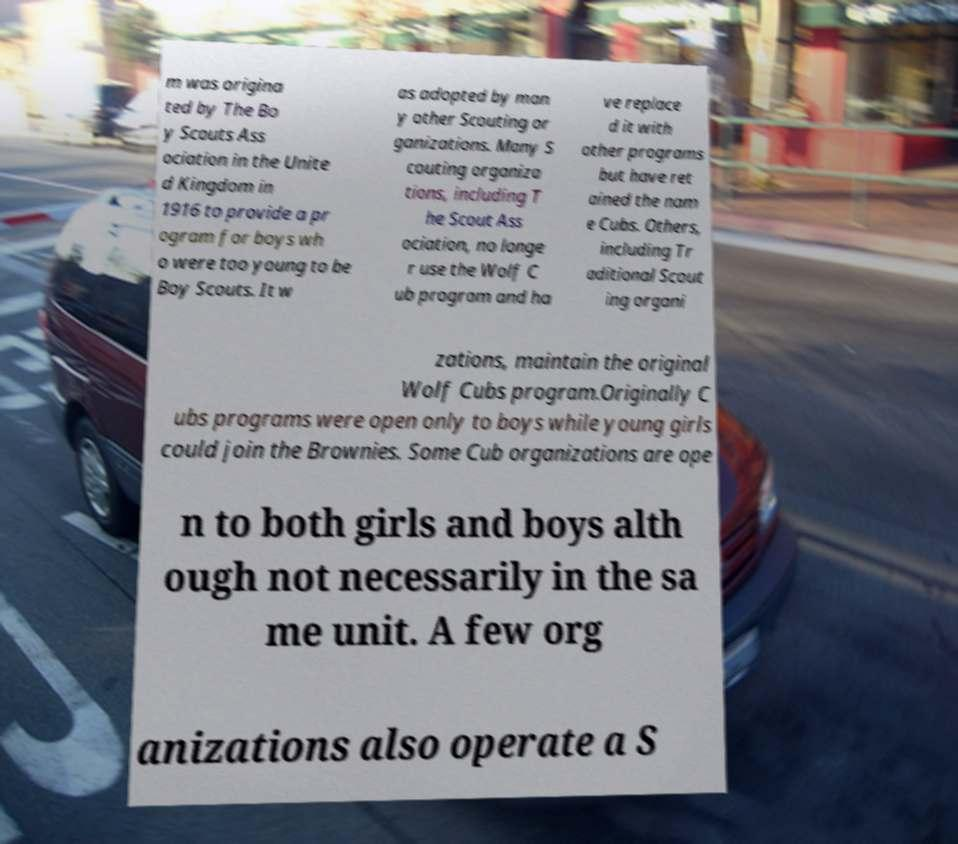What messages or text are displayed in this image? I need them in a readable, typed format. m was origina ted by The Bo y Scouts Ass ociation in the Unite d Kingdom in 1916 to provide a pr ogram for boys wh o were too young to be Boy Scouts. It w as adopted by man y other Scouting or ganizations. Many S couting organiza tions, including T he Scout Ass ociation, no longe r use the Wolf C ub program and ha ve replace d it with other programs but have ret ained the nam e Cubs. Others, including Tr aditional Scout ing organi zations, maintain the original Wolf Cubs program.Originally C ubs programs were open only to boys while young girls could join the Brownies. Some Cub organizations are ope n to both girls and boys alth ough not necessarily in the sa me unit. A few org anizations also operate a S 